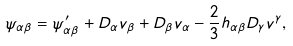<formula> <loc_0><loc_0><loc_500><loc_500>\psi _ { \alpha \beta } = \psi ^ { \prime } _ { \alpha \beta } + D _ { \alpha } v _ { \beta } + D _ { \beta } v _ { \alpha } - \frac { 2 } { 3 } h _ { \alpha \beta } D _ { \gamma } v ^ { \gamma } ,</formula> 